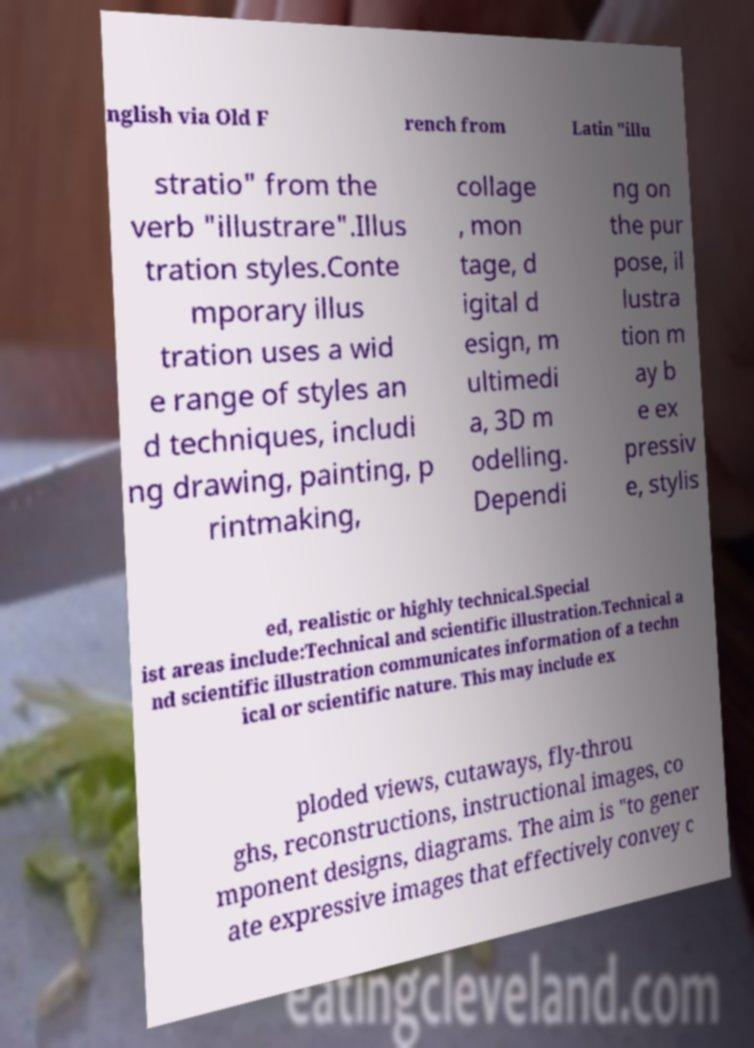Can you accurately transcribe the text from the provided image for me? nglish via Old F rench from Latin "illu stratio" from the verb "illustrare".Illus tration styles.Conte mporary illus tration uses a wid e range of styles an d techniques, includi ng drawing, painting, p rintmaking, collage , mon tage, d igital d esign, m ultimedi a, 3D m odelling. Dependi ng on the pur pose, il lustra tion m ay b e ex pressiv e, stylis ed, realistic or highly technical.Special ist areas include:Technical and scientific illustration.Technical a nd scientific illustration communicates information of a techn ical or scientific nature. This may include ex ploded views, cutaways, fly-throu ghs, reconstructions, instructional images, co mponent designs, diagrams. The aim is "to gener ate expressive images that effectively convey c 